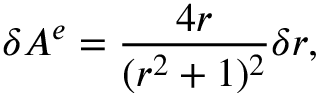<formula> <loc_0><loc_0><loc_500><loc_500>\delta A ^ { e } = { \frac { 4 r } { ( r ^ { 2 } + 1 ) ^ { 2 } } } \delta r ,</formula> 